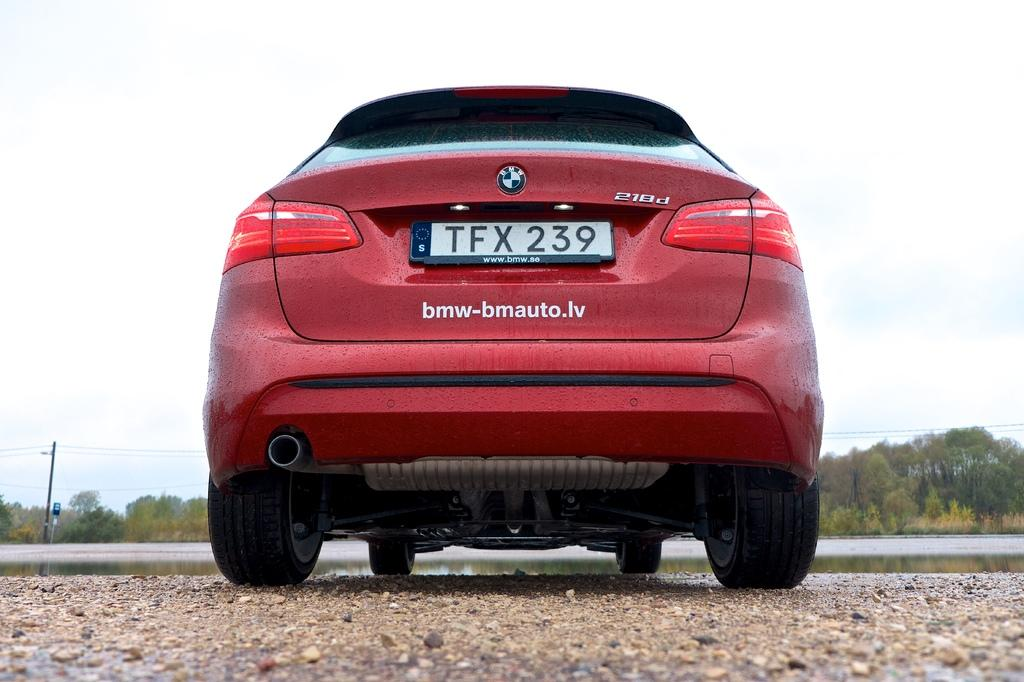What is the main subject in the foreground of the image? There is a car in the foreground of the image. What can be seen in the background of the image? There are trees, poles, and wires in the background of the image. What is visible at the bottom of the image? There is water and sand visible at the bottom of the image. Can you see the moon in the image? The moon is not visible in the image; it features a car in the foreground, trees, poles, and wires in the background, and water and sand at the bottom. Are there any trucks visible in the image? There are no trucks present in the image; it features a car in the foreground and other elements as described. 